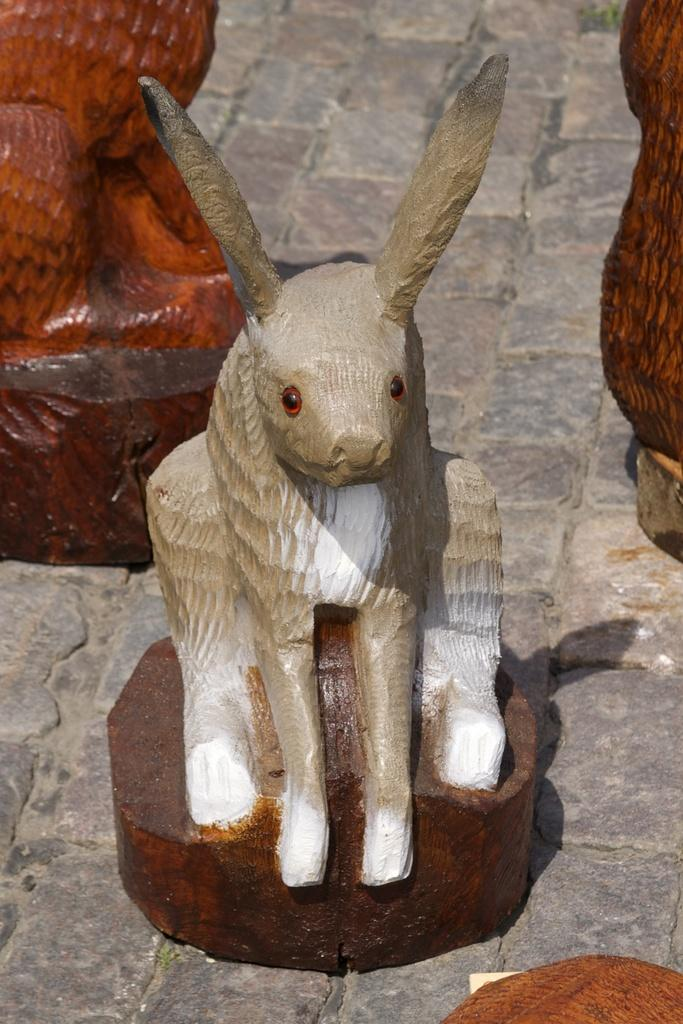What is the main subject of the image? There is a statue in the image. What type of statue is it? The statue is of an animal. What type of thrill can be seen on the statue's face in the image? There is no indication of a face or any emotions on the statue in the image, as it is a statue of an animal. 